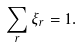Convert formula to latex. <formula><loc_0><loc_0><loc_500><loc_500>\sum _ { r } \xi _ { r } = 1 .</formula> 